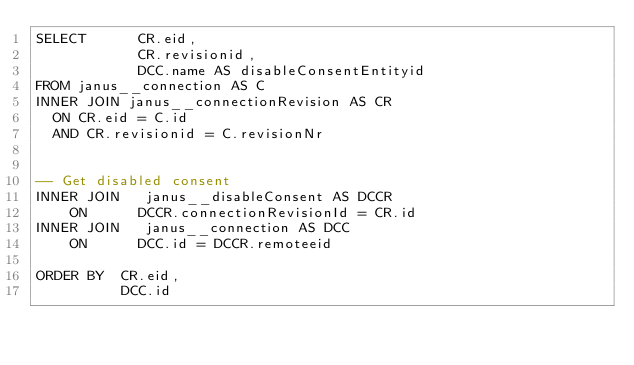Convert code to text. <code><loc_0><loc_0><loc_500><loc_500><_SQL_>SELECT      CR.eid,
            CR.revisionid,
            DCC.name AS disableConsentEntityid
FROM janus__connection AS C
INNER JOIN janus__connectionRevision AS CR
  ON CR.eid = C.id
  AND CR.revisionid = C.revisionNr


-- Get disabled consent
INNER JOIN   janus__disableConsent AS DCCR
    ON      DCCR.connectionRevisionId = CR.id
INNER JOIN   janus__connection AS DCC
    ON      DCC.id = DCCR.remoteeid

ORDER BY  CR.eid,
          DCC.id

</code> 